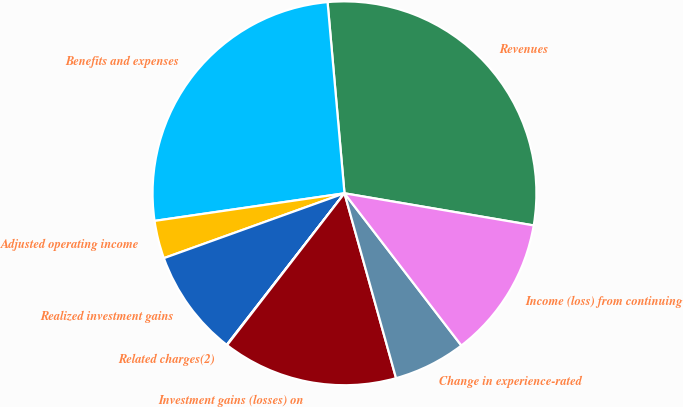<chart> <loc_0><loc_0><loc_500><loc_500><pie_chart><fcel>Revenues<fcel>Benefits and expenses<fcel>Adjusted operating income<fcel>Realized investment gains<fcel>Related charges(2)<fcel>Investment gains (losses) on<fcel>Change in experience-rated<fcel>Income (loss) from continuing<nl><fcel>29.08%<fcel>25.89%<fcel>3.19%<fcel>9.0%<fcel>0.04%<fcel>14.8%<fcel>6.09%<fcel>11.9%<nl></chart> 